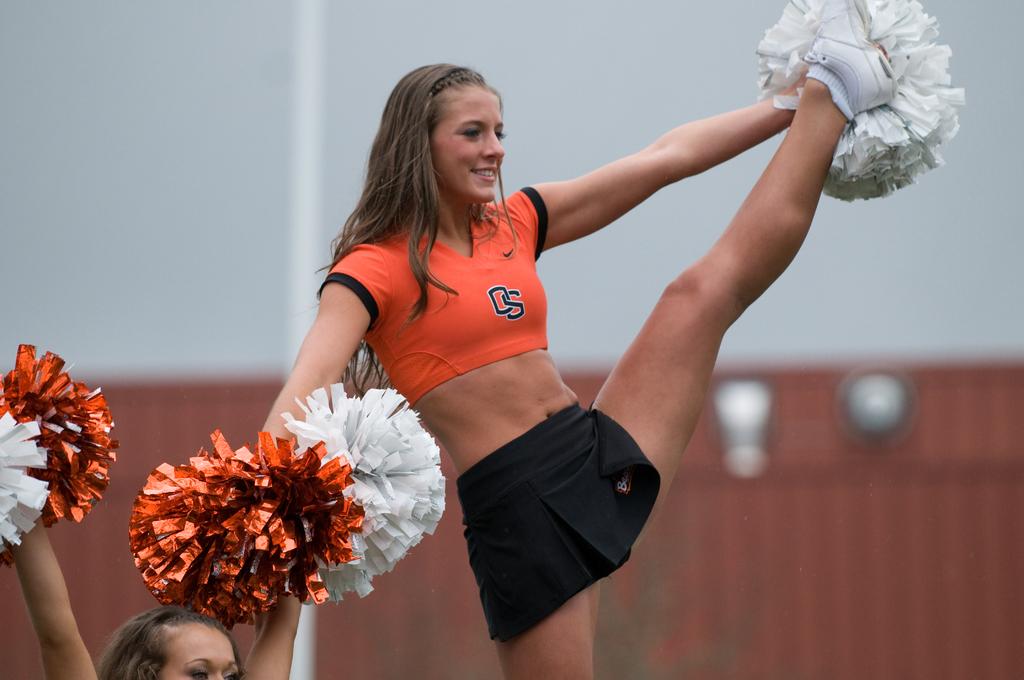Which team does the cheerleader cheer for?
Give a very brief answer. Os. 